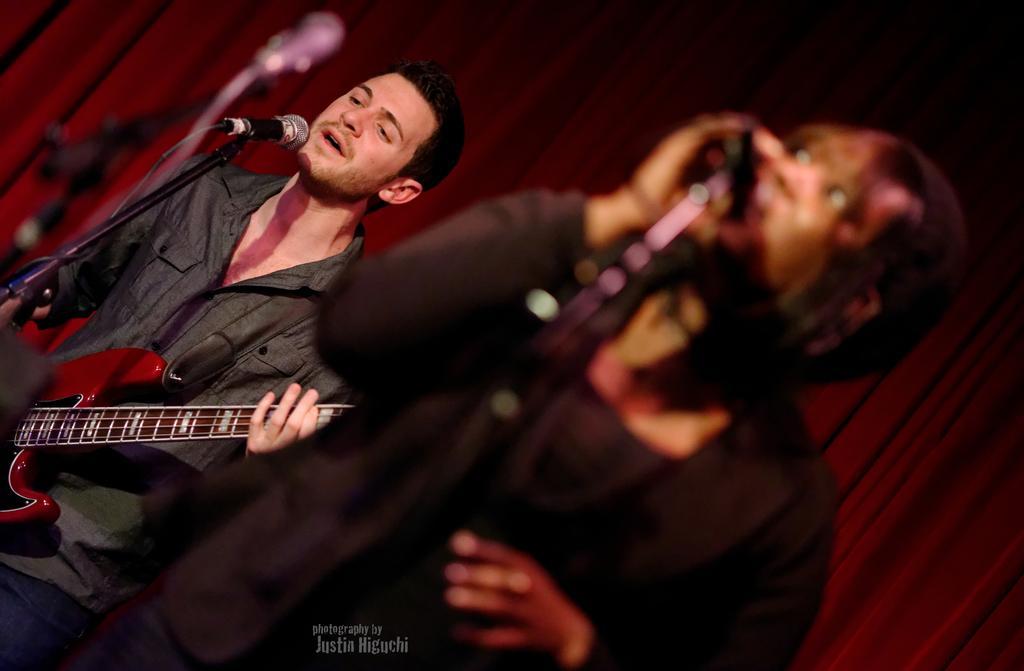How would you summarize this image in a sentence or two? In this image I can see two persons standing and singing on the mikes. This man is playing the guitar. In the background there is a curtain. 